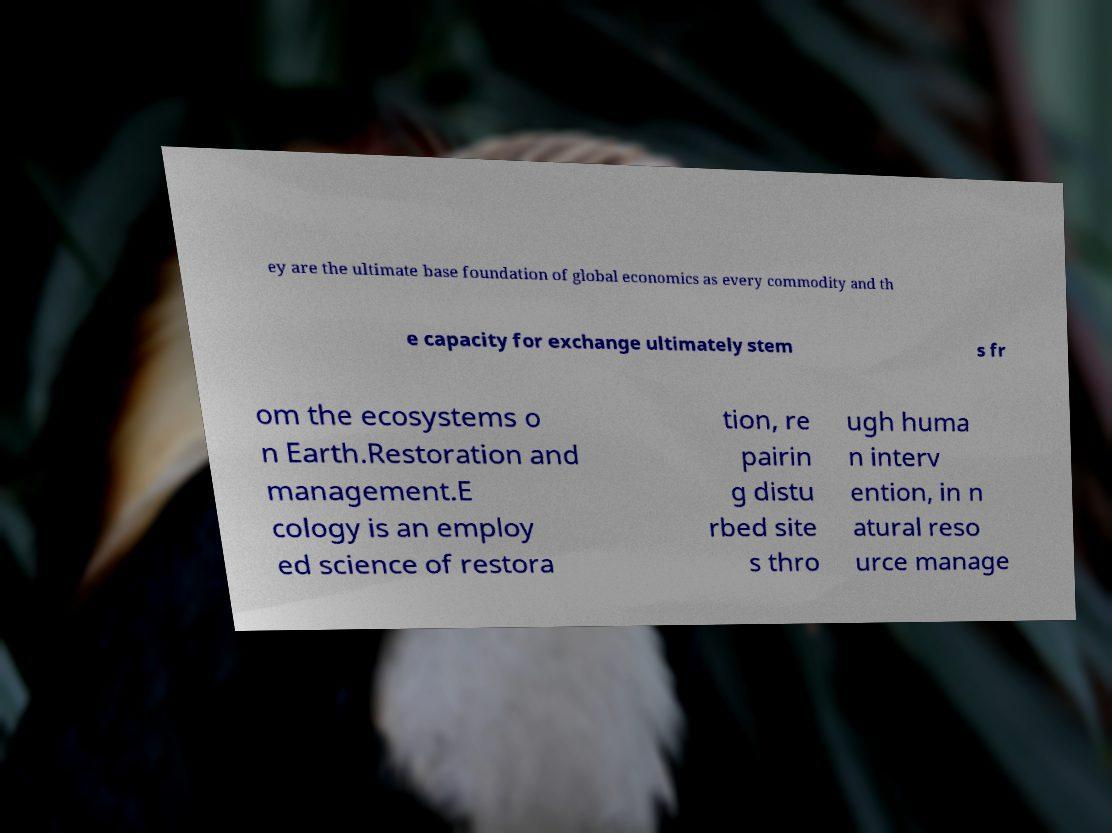There's text embedded in this image that I need extracted. Can you transcribe it verbatim? ey are the ultimate base foundation of global economics as every commodity and th e capacity for exchange ultimately stem s fr om the ecosystems o n Earth.Restoration and management.E cology is an employ ed science of restora tion, re pairin g distu rbed site s thro ugh huma n interv ention, in n atural reso urce manage 